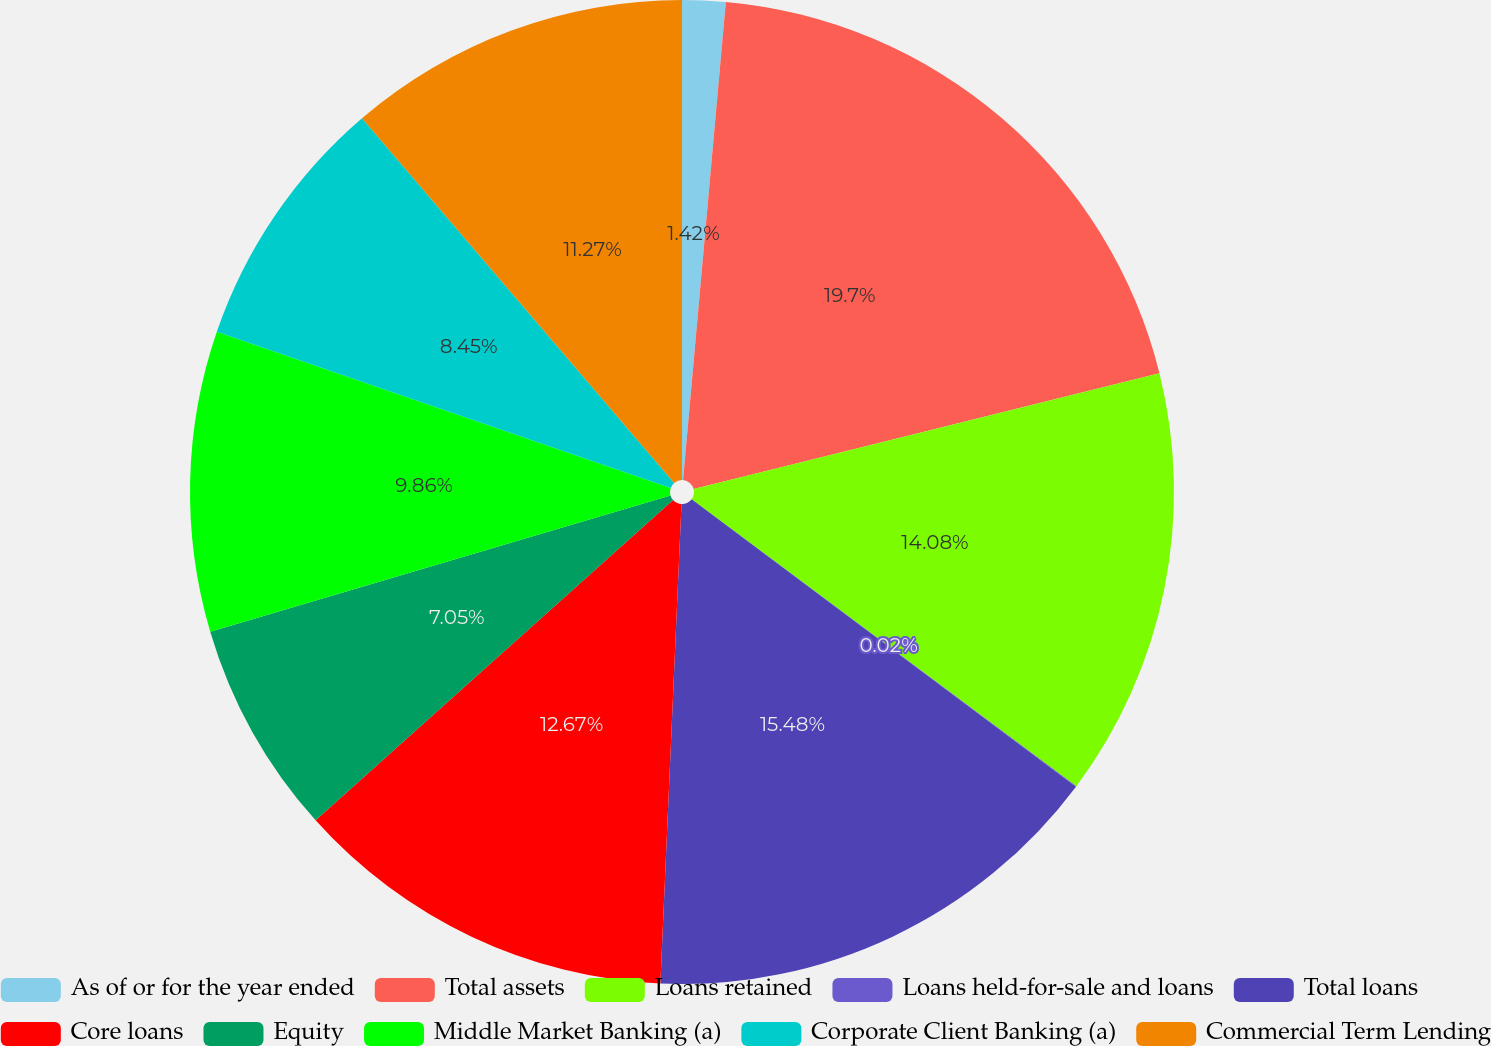Convert chart to OTSL. <chart><loc_0><loc_0><loc_500><loc_500><pie_chart><fcel>As of or for the year ended<fcel>Total assets<fcel>Loans retained<fcel>Loans held-for-sale and loans<fcel>Total loans<fcel>Core loans<fcel>Equity<fcel>Middle Market Banking (a)<fcel>Corporate Client Banking (a)<fcel>Commercial Term Lending<nl><fcel>1.42%<fcel>19.7%<fcel>14.08%<fcel>0.02%<fcel>15.48%<fcel>12.67%<fcel>7.05%<fcel>9.86%<fcel>8.45%<fcel>11.27%<nl></chart> 